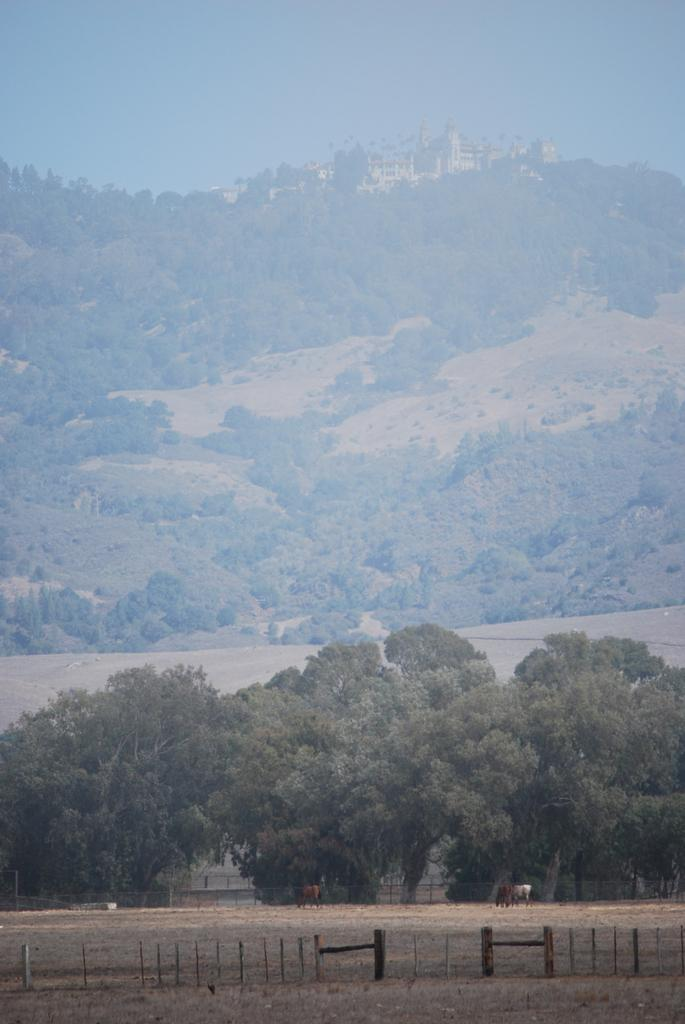What type of landscape is depicted in the image? There is a field in the image. What animals can be seen in the field? There are horses in the field. What surrounds the field? There is fencing around the field. What can be seen in the background of the image? There are trees and a mountain in the background of the image. What is visible at the top of the image? The sky is visible in the image. What type of steel is used to construct the dinner table in the image? There is no dinner table present in the image; it features a field with horses and fencing. How does the stretch of the mountain affect the horses in the image? The image does not show any stretching of the mountain or its effect on the horses; it simply depicts a field with horses and a mountain in the background. 